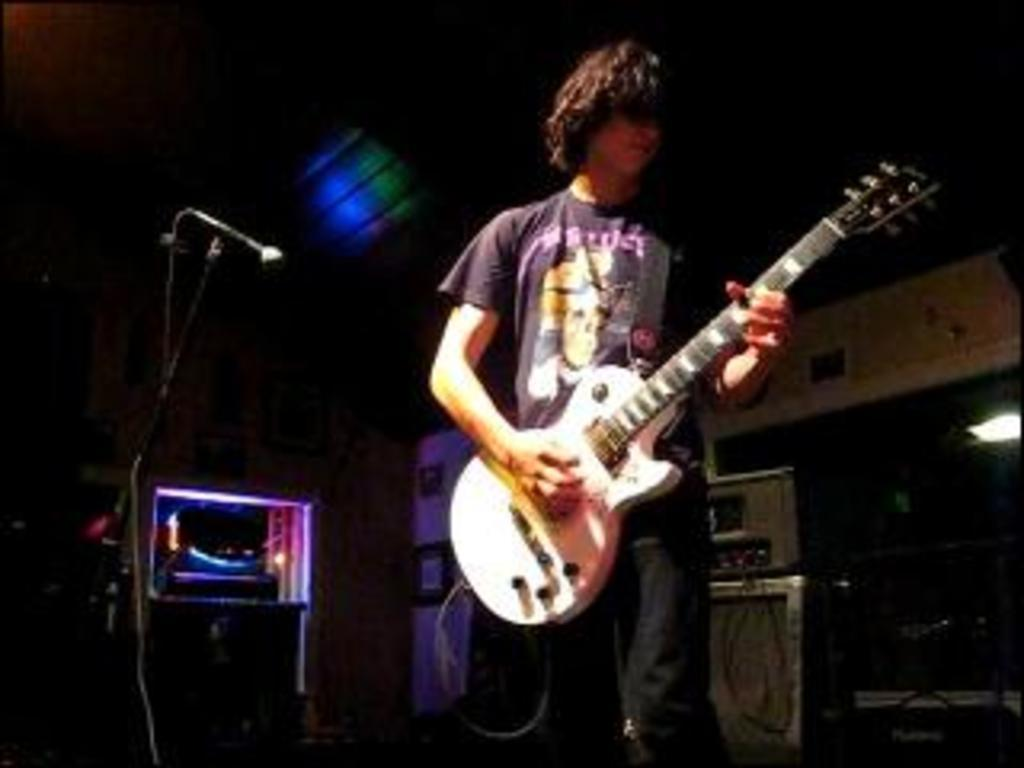What is the main subject of the image? The main subject of the image is a boy. Where is the boy positioned in the image? The boy is standing in the middle of the image. What is the boy holding in the image? The boy is holding a white-colored music instrument. What other object can be seen on the left side of the image? There is a black-colored microphone on the left side of the image. How many bikes are visible in the image? There are no bikes present in the image. What type of destruction can be seen happening in the image? There is no destruction present in the image; it features a boy holding a music instrument and a microphone. 